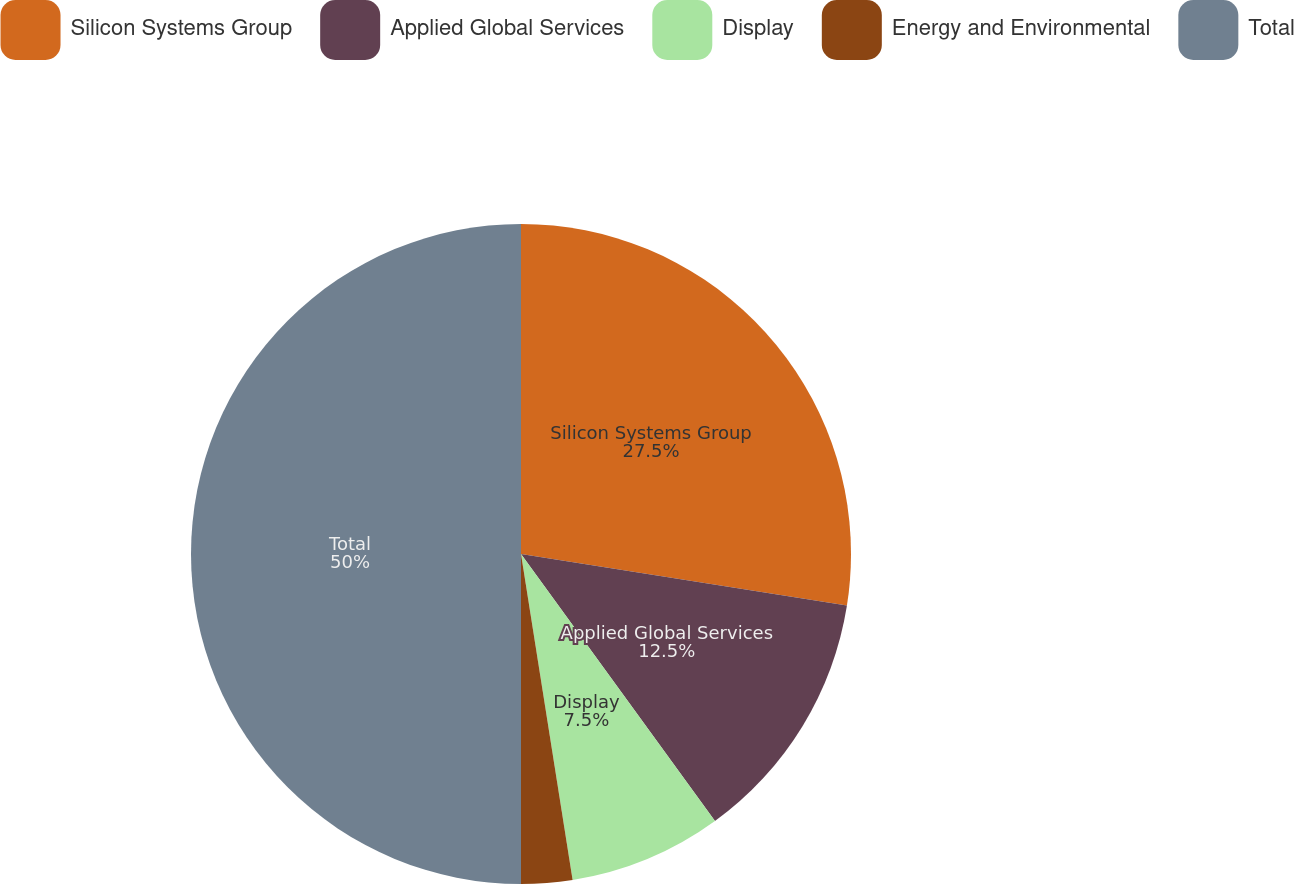Convert chart. <chart><loc_0><loc_0><loc_500><loc_500><pie_chart><fcel>Silicon Systems Group<fcel>Applied Global Services<fcel>Display<fcel>Energy and Environmental<fcel>Total<nl><fcel>27.5%<fcel>12.5%<fcel>7.5%<fcel>2.5%<fcel>50.0%<nl></chart> 